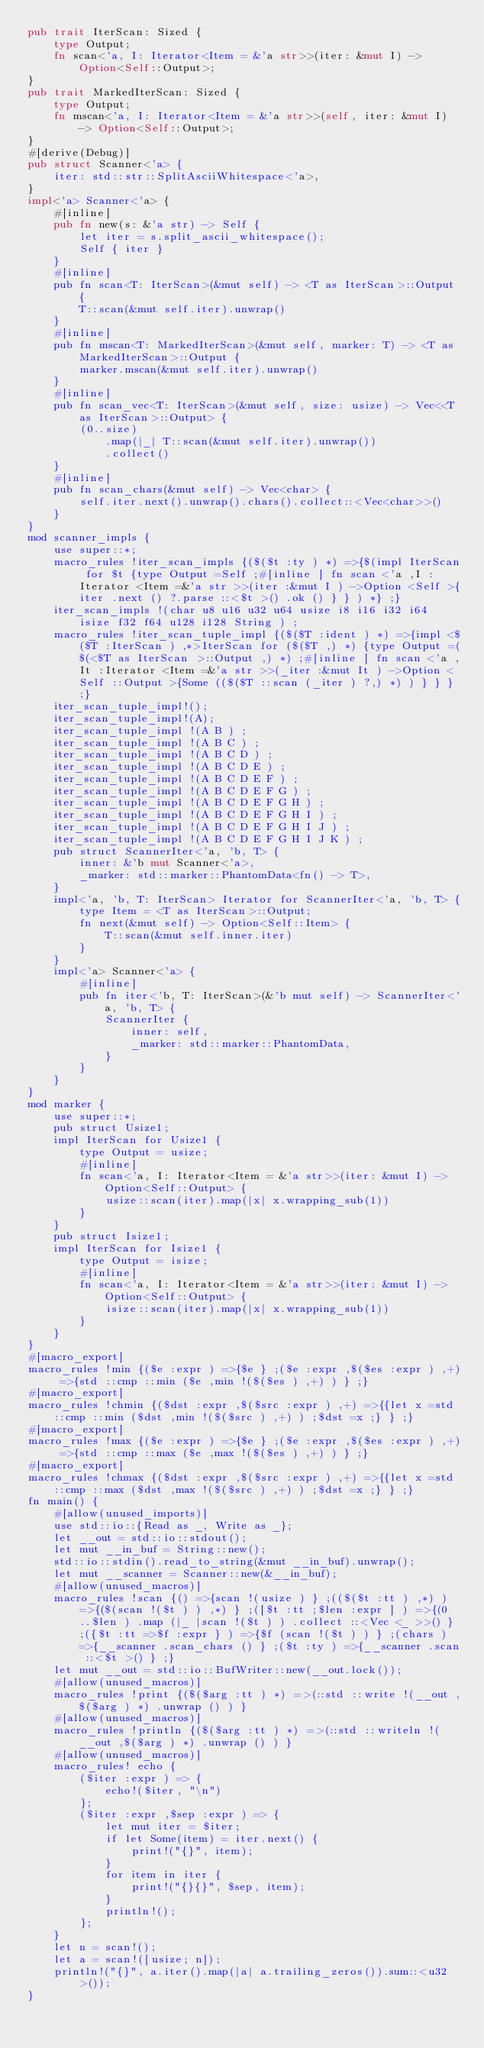<code> <loc_0><loc_0><loc_500><loc_500><_Rust_>pub trait IterScan: Sized {
    type Output;
    fn scan<'a, I: Iterator<Item = &'a str>>(iter: &mut I) -> Option<Self::Output>;
}
pub trait MarkedIterScan: Sized {
    type Output;
    fn mscan<'a, I: Iterator<Item = &'a str>>(self, iter: &mut I) -> Option<Self::Output>;
}
#[derive(Debug)]
pub struct Scanner<'a> {
    iter: std::str::SplitAsciiWhitespace<'a>,
}
impl<'a> Scanner<'a> {
    #[inline]
    pub fn new(s: &'a str) -> Self {
        let iter = s.split_ascii_whitespace();
        Self { iter }
    }
    #[inline]
    pub fn scan<T: IterScan>(&mut self) -> <T as IterScan>::Output {
        T::scan(&mut self.iter).unwrap()
    }
    #[inline]
    pub fn mscan<T: MarkedIterScan>(&mut self, marker: T) -> <T as MarkedIterScan>::Output {
        marker.mscan(&mut self.iter).unwrap()
    }
    #[inline]
    pub fn scan_vec<T: IterScan>(&mut self, size: usize) -> Vec<<T as IterScan>::Output> {
        (0..size)
            .map(|_| T::scan(&mut self.iter).unwrap())
            .collect()
    }
    #[inline]
    pub fn scan_chars(&mut self) -> Vec<char> {
        self.iter.next().unwrap().chars().collect::<Vec<char>>()
    }
}
mod scanner_impls {
    use super::*;
    macro_rules !iter_scan_impls {($($t :ty ) *) =>{$(impl IterScan for $t {type Output =Self ;#[inline ] fn scan <'a ,I :Iterator <Item =&'a str >>(iter :&mut I ) ->Option <Self >{iter .next () ?.parse ::<$t >() .ok () } } ) *} ;}
    iter_scan_impls !(char u8 u16 u32 u64 usize i8 i16 i32 i64 isize f32 f64 u128 i128 String ) ;
    macro_rules !iter_scan_tuple_impl {($($T :ident ) *) =>{impl <$($T :IterScan ) ,*>IterScan for ($($T ,) *) {type Output =($(<$T as IterScan >::Output ,) *) ;#[inline ] fn scan <'a ,It :Iterator <Item =&'a str >>(_iter :&mut It ) ->Option <Self ::Output >{Some (($($T ::scan (_iter ) ?,) *) ) } } } ;}
    iter_scan_tuple_impl!();
    iter_scan_tuple_impl!(A);
    iter_scan_tuple_impl !(A B ) ;
    iter_scan_tuple_impl !(A B C ) ;
    iter_scan_tuple_impl !(A B C D ) ;
    iter_scan_tuple_impl !(A B C D E ) ;
    iter_scan_tuple_impl !(A B C D E F ) ;
    iter_scan_tuple_impl !(A B C D E F G ) ;
    iter_scan_tuple_impl !(A B C D E F G H ) ;
    iter_scan_tuple_impl !(A B C D E F G H I ) ;
    iter_scan_tuple_impl !(A B C D E F G H I J ) ;
    iter_scan_tuple_impl !(A B C D E F G H I J K ) ;
    pub struct ScannerIter<'a, 'b, T> {
        inner: &'b mut Scanner<'a>,
        _marker: std::marker::PhantomData<fn() -> T>,
    }
    impl<'a, 'b, T: IterScan> Iterator for ScannerIter<'a, 'b, T> {
        type Item = <T as IterScan>::Output;
        fn next(&mut self) -> Option<Self::Item> {
            T::scan(&mut self.inner.iter)
        }
    }
    impl<'a> Scanner<'a> {
        #[inline]
        pub fn iter<'b, T: IterScan>(&'b mut self) -> ScannerIter<'a, 'b, T> {
            ScannerIter {
                inner: self,
                _marker: std::marker::PhantomData,
            }
        }
    }
}
mod marker {
    use super::*;
    pub struct Usize1;
    impl IterScan for Usize1 {
        type Output = usize;
        #[inline]
        fn scan<'a, I: Iterator<Item = &'a str>>(iter: &mut I) -> Option<Self::Output> {
            usize::scan(iter).map(|x| x.wrapping_sub(1))
        }
    }
    pub struct Isize1;
    impl IterScan for Isize1 {
        type Output = isize;
        #[inline]
        fn scan<'a, I: Iterator<Item = &'a str>>(iter: &mut I) -> Option<Self::Output> {
            isize::scan(iter).map(|x| x.wrapping_sub(1))
        }
    }
}
#[macro_export]
macro_rules !min {($e :expr ) =>{$e } ;($e :expr ,$($es :expr ) ,+) =>{std ::cmp ::min ($e ,min !($($es ) ,+) ) } ;}
#[macro_export]
macro_rules !chmin {($dst :expr ,$($src :expr ) ,+) =>{{let x =std ::cmp ::min ($dst ,min !($($src ) ,+) ) ;$dst =x ;} } ;}
#[macro_export]
macro_rules !max {($e :expr ) =>{$e } ;($e :expr ,$($es :expr ) ,+) =>{std ::cmp ::max ($e ,max !($($es ) ,+) ) } ;}
#[macro_export]
macro_rules !chmax {($dst :expr ,$($src :expr ) ,+) =>{{let x =std ::cmp ::max ($dst ,max !($($src ) ,+) ) ;$dst =x ;} } ;}
fn main() {
    #[allow(unused_imports)]
    use std::io::{Read as _, Write as _};
    let __out = std::io::stdout();
    let mut __in_buf = String::new();
    std::io::stdin().read_to_string(&mut __in_buf).unwrap();
    let mut __scanner = Scanner::new(&__in_buf);
    #[allow(unused_macros)]
    macro_rules !scan {() =>{scan !(usize ) } ;(($($t :tt ) ,*) ) =>{($(scan !($t ) ) ,*) } ;([$t :tt ;$len :expr ] ) =>{(0 ..$len ) .map (|_ |scan !($t ) ) .collect ::<Vec <_ >>() } ;({$t :tt =>$f :expr } ) =>{$f (scan !($t ) ) } ;(chars ) =>{__scanner .scan_chars () } ;($t :ty ) =>{__scanner .scan ::<$t >() } ;}
    let mut __out = std::io::BufWriter::new(__out.lock());
    #[allow(unused_macros)]
    macro_rules !print {($($arg :tt ) *) =>(::std ::write !(__out ,$($arg ) *) .unwrap () ) }
    #[allow(unused_macros)]
    macro_rules !println {($($arg :tt ) *) =>(::std ::writeln !(__out ,$($arg ) *) .unwrap () ) }
    #[allow(unused_macros)]
    macro_rules! echo {
        ($iter :expr ) => {
            echo!($iter, "\n")
        };
        ($iter :expr ,$sep :expr ) => {
            let mut iter = $iter;
            if let Some(item) = iter.next() {
                print!("{}", item);
            }
            for item in iter {
                print!("{}{}", $sep, item);
            }
            println!();
        };
    }
    let n = scan!();
    let a = scan!([usize; n]);
    println!("{}", a.iter().map(|a| a.trailing_zeros()).sum::<u32>());
}</code> 